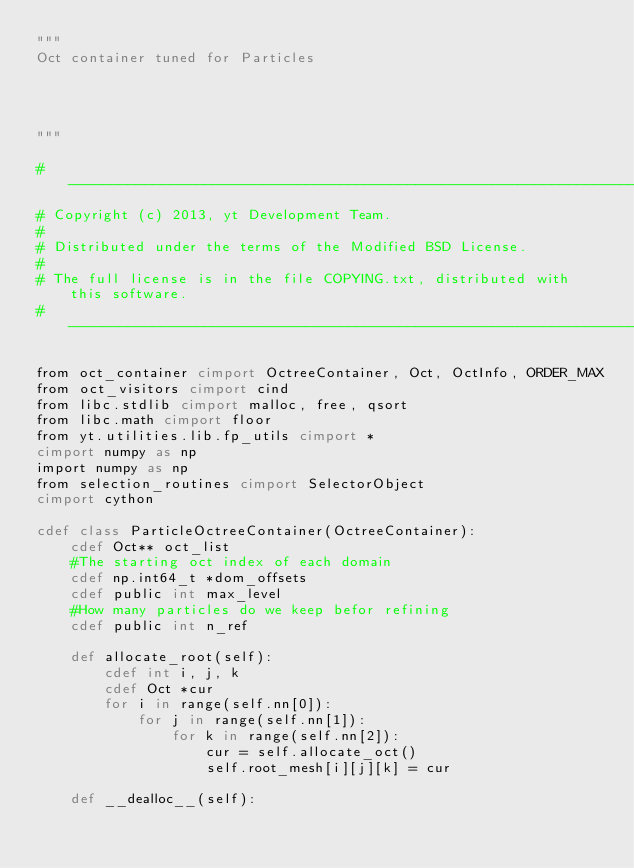Convert code to text. <code><loc_0><loc_0><loc_500><loc_500><_Cython_>"""
Oct container tuned for Particles




"""

#-----------------------------------------------------------------------------
# Copyright (c) 2013, yt Development Team.
#
# Distributed under the terms of the Modified BSD License.
#
# The full license is in the file COPYING.txt, distributed with this software.
#-----------------------------------------------------------------------------

from oct_container cimport OctreeContainer, Oct, OctInfo, ORDER_MAX
from oct_visitors cimport cind
from libc.stdlib cimport malloc, free, qsort
from libc.math cimport floor
from yt.utilities.lib.fp_utils cimport *
cimport numpy as np
import numpy as np
from selection_routines cimport SelectorObject
cimport cython

cdef class ParticleOctreeContainer(OctreeContainer):
    cdef Oct** oct_list
    #The starting oct index of each domain
    cdef np.int64_t *dom_offsets
    cdef public int max_level
    #How many particles do we keep befor refining
    cdef public int n_ref

    def allocate_root(self):
        cdef int i, j, k
        cdef Oct *cur
        for i in range(self.nn[0]):
            for j in range(self.nn[1]):
                for k in range(self.nn[2]):
                    cur = self.allocate_oct()
                    self.root_mesh[i][j][k] = cur

    def __dealloc__(self):</code> 